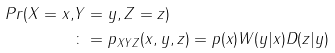Convert formula to latex. <formula><loc_0><loc_0><loc_500><loc_500>P r ( X = x , & Y = y , Z = z ) \\ & \colon = p _ { X Y Z } ( x , y , z ) = p ( x ) W ( y | x ) D ( z | y )</formula> 